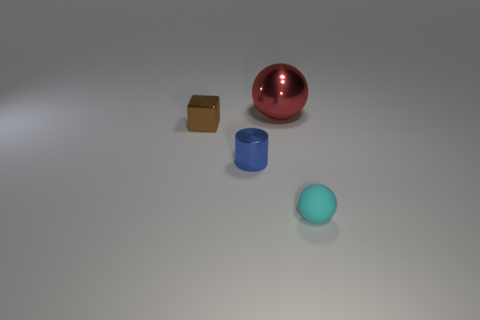Add 2 large brown metallic cubes. How many objects exist? 6 Subtract 1 cylinders. How many cylinders are left? 0 Add 4 small balls. How many small balls exist? 5 Subtract 0 green cubes. How many objects are left? 4 Subtract all blocks. How many objects are left? 3 Subtract all yellow balls. Subtract all red cubes. How many balls are left? 2 Subtract all green cylinders. How many yellow blocks are left? 0 Subtract all tiny rubber spheres. Subtract all tiny blue cylinders. How many objects are left? 2 Add 2 cyan spheres. How many cyan spheres are left? 3 